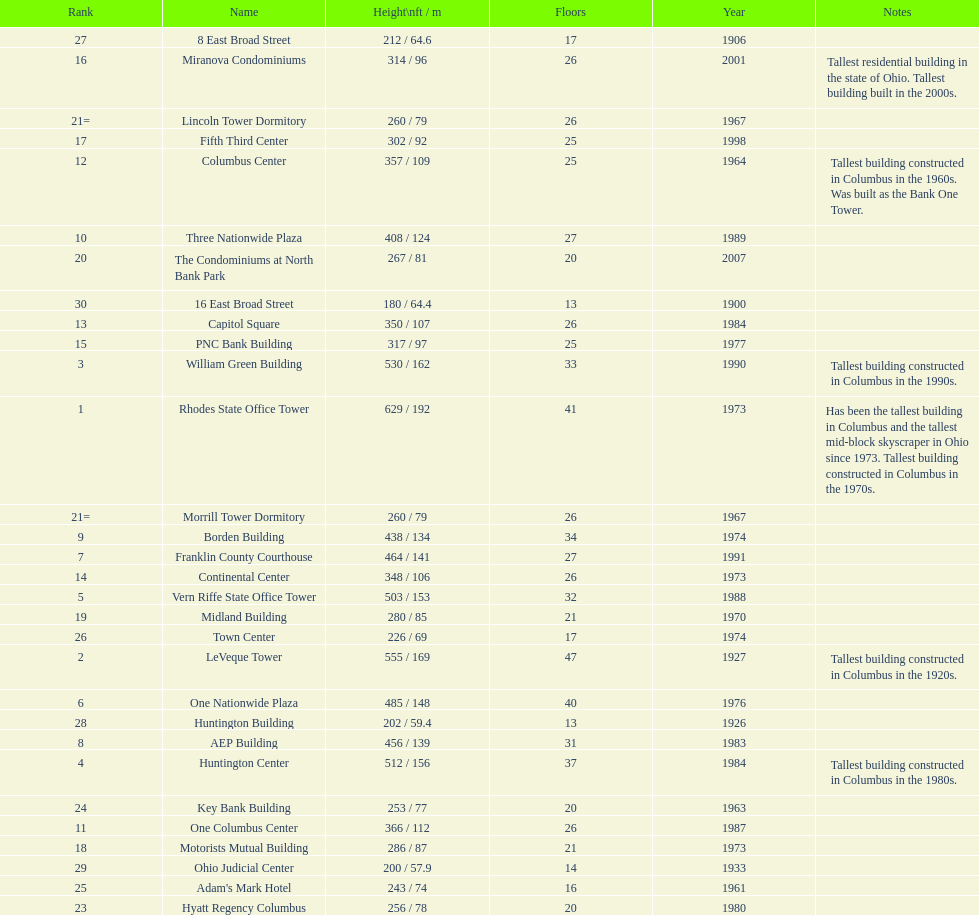Which is the tallest building? Rhodes State Office Tower. 